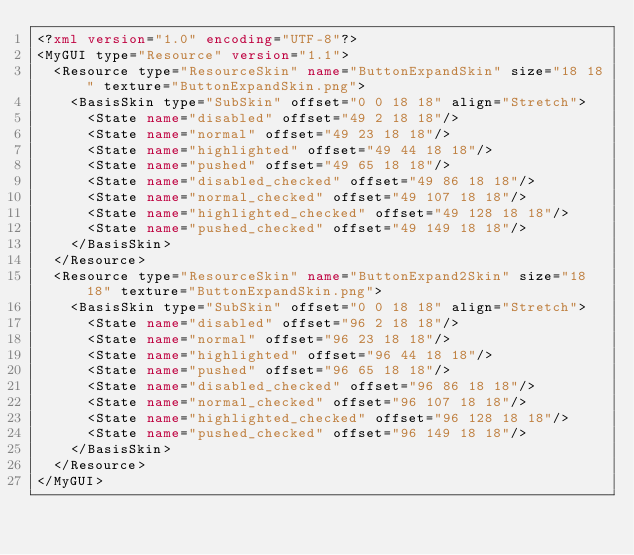<code> <loc_0><loc_0><loc_500><loc_500><_XML_><?xml version="1.0" encoding="UTF-8"?>
<MyGUI type="Resource" version="1.1">
	<Resource type="ResourceSkin" name="ButtonExpandSkin" size="18 18" texture="ButtonExpandSkin.png">
		<BasisSkin type="SubSkin" offset="0 0 18 18" align="Stretch">
			<State name="disabled" offset="49 2 18 18"/>
			<State name="normal" offset="49 23 18 18"/>
			<State name="highlighted" offset="49 44 18 18"/>
			<State name="pushed" offset="49 65 18 18"/>
			<State name="disabled_checked" offset="49 86 18 18"/>
			<State name="normal_checked" offset="49 107 18 18"/>
			<State name="highlighted_checked" offset="49 128 18 18"/>
			<State name="pushed_checked" offset="49 149 18 18"/>
		</BasisSkin>
	</Resource>
	<Resource type="ResourceSkin" name="ButtonExpand2Skin" size="18 18" texture="ButtonExpandSkin.png">
		<BasisSkin type="SubSkin" offset="0 0 18 18" align="Stretch">
			<State name="disabled" offset="96 2 18 18"/>
			<State name="normal" offset="96 23 18 18"/>
			<State name="highlighted" offset="96 44 18 18"/>
			<State name="pushed" offset="96 65 18 18"/>
			<State name="disabled_checked" offset="96 86 18 18"/>
			<State name="normal_checked" offset="96 107 18 18"/>
			<State name="highlighted_checked" offset="96 128 18 18"/>
			<State name="pushed_checked" offset="96 149 18 18"/>
		</BasisSkin>
	</Resource>
</MyGUI>
</code> 